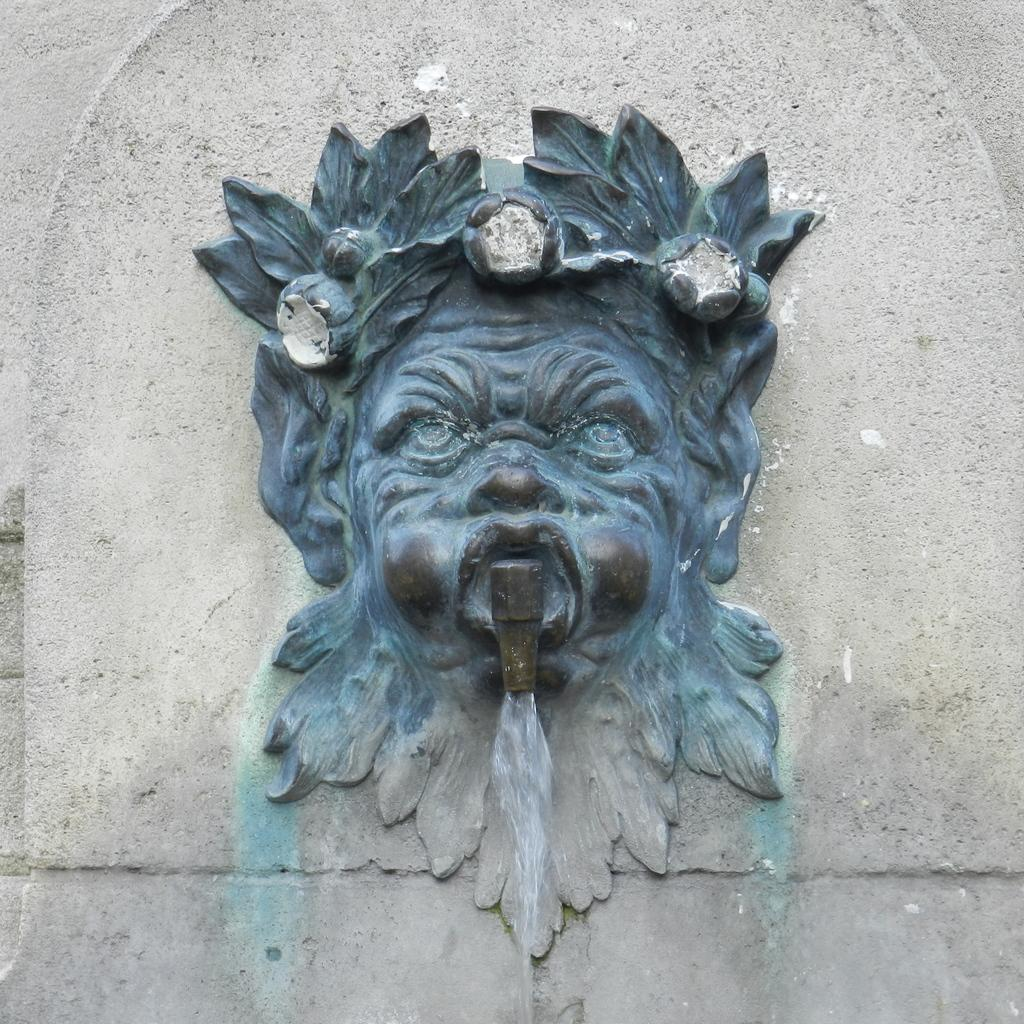What is the main subject of the image? The main subject of the image is a sculpture. What material is the sculpture made of? The sculpture is carved on a stone. What type of bell can be heard ringing in the image? There is no bell present in the image, and therefore no sound can be heard. 